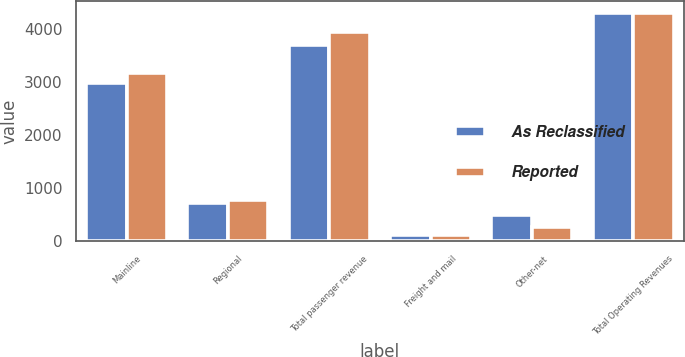Convert chart to OTSL. <chart><loc_0><loc_0><loc_500><loc_500><stacked_bar_chart><ecel><fcel>Mainline<fcel>Regional<fcel>Total passenger revenue<fcel>Freight and mail<fcel>Other-net<fcel>Total Operating Revenues<nl><fcel>As Reclassified<fcel>2995<fcel>713<fcel>3708<fcel>109<fcel>501<fcel>4318<nl><fcel>Reported<fcel>3176<fcel>775<fcel>3951<fcel>109<fcel>258<fcel>4318<nl></chart> 